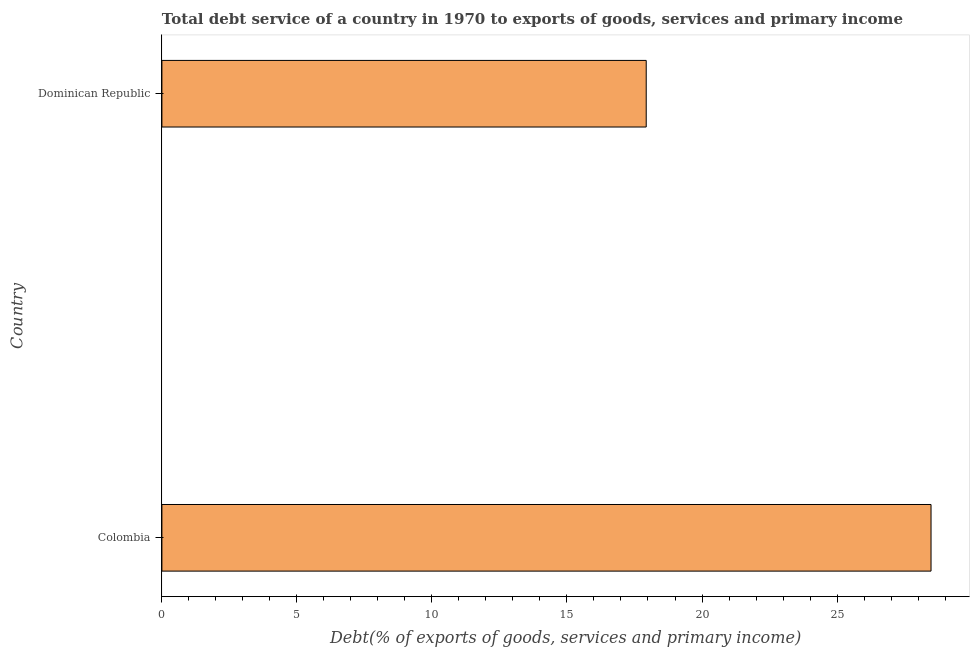Does the graph contain grids?
Ensure brevity in your answer.  No. What is the title of the graph?
Keep it short and to the point. Total debt service of a country in 1970 to exports of goods, services and primary income. What is the label or title of the X-axis?
Keep it short and to the point. Debt(% of exports of goods, services and primary income). What is the label or title of the Y-axis?
Give a very brief answer. Country. What is the total debt service in Dominican Republic?
Offer a very short reply. 17.93. Across all countries, what is the maximum total debt service?
Keep it short and to the point. 28.48. Across all countries, what is the minimum total debt service?
Provide a succinct answer. 17.93. In which country was the total debt service minimum?
Provide a short and direct response. Dominican Republic. What is the sum of the total debt service?
Ensure brevity in your answer.  46.42. What is the difference between the total debt service in Colombia and Dominican Republic?
Offer a terse response. 10.55. What is the average total debt service per country?
Keep it short and to the point. 23.21. What is the median total debt service?
Your response must be concise. 23.21. What is the ratio of the total debt service in Colombia to that in Dominican Republic?
Ensure brevity in your answer.  1.59. Is the total debt service in Colombia less than that in Dominican Republic?
Ensure brevity in your answer.  No. How many bars are there?
Provide a short and direct response. 2. How many countries are there in the graph?
Keep it short and to the point. 2. What is the Debt(% of exports of goods, services and primary income) in Colombia?
Your answer should be very brief. 28.48. What is the Debt(% of exports of goods, services and primary income) of Dominican Republic?
Give a very brief answer. 17.93. What is the difference between the Debt(% of exports of goods, services and primary income) in Colombia and Dominican Republic?
Provide a succinct answer. 10.55. What is the ratio of the Debt(% of exports of goods, services and primary income) in Colombia to that in Dominican Republic?
Ensure brevity in your answer.  1.59. 